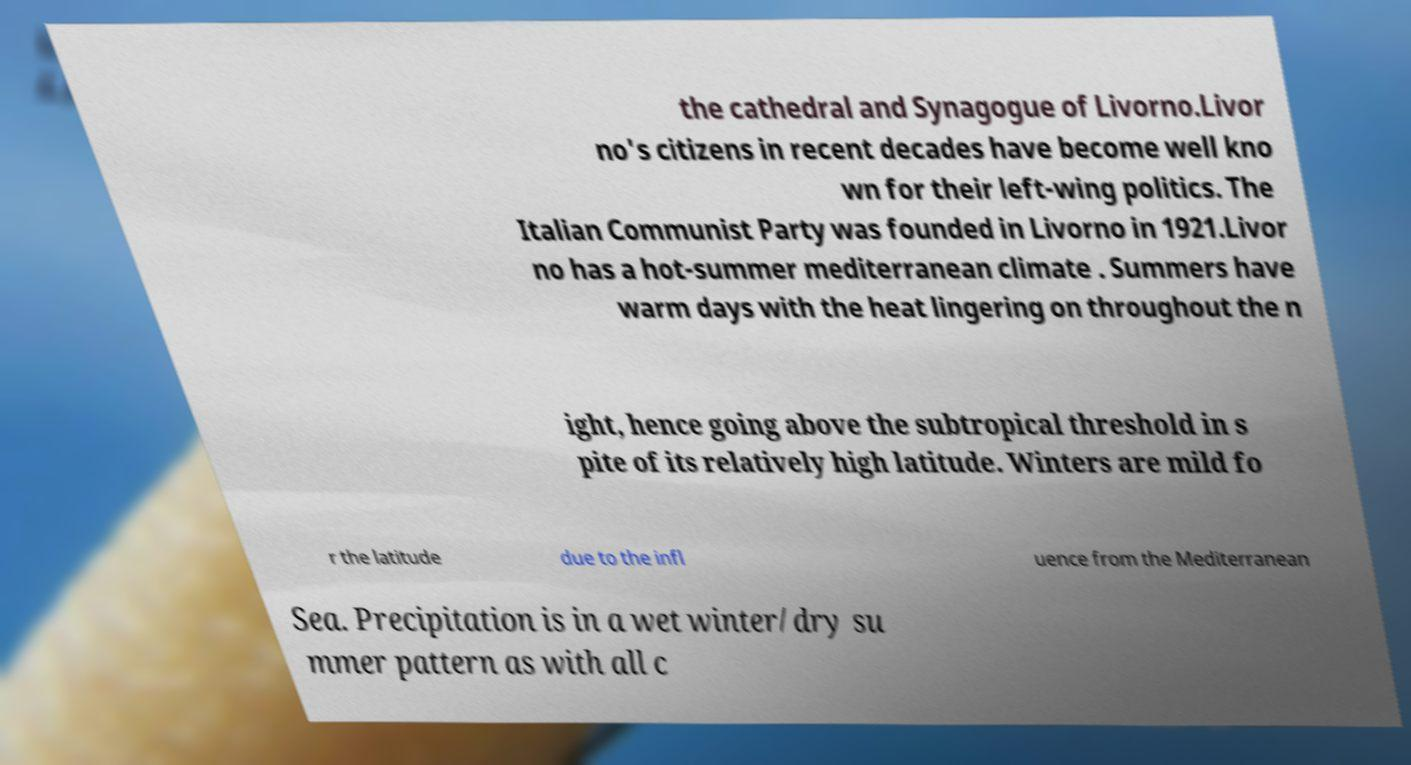Can you accurately transcribe the text from the provided image for me? the cathedral and Synagogue of Livorno.Livor no's citizens in recent decades have become well kno wn for their left-wing politics. The Italian Communist Party was founded in Livorno in 1921.Livor no has a hot-summer mediterranean climate . Summers have warm days with the heat lingering on throughout the n ight, hence going above the subtropical threshold in s pite of its relatively high latitude. Winters are mild fo r the latitude due to the infl uence from the Mediterranean Sea. Precipitation is in a wet winter/dry su mmer pattern as with all c 